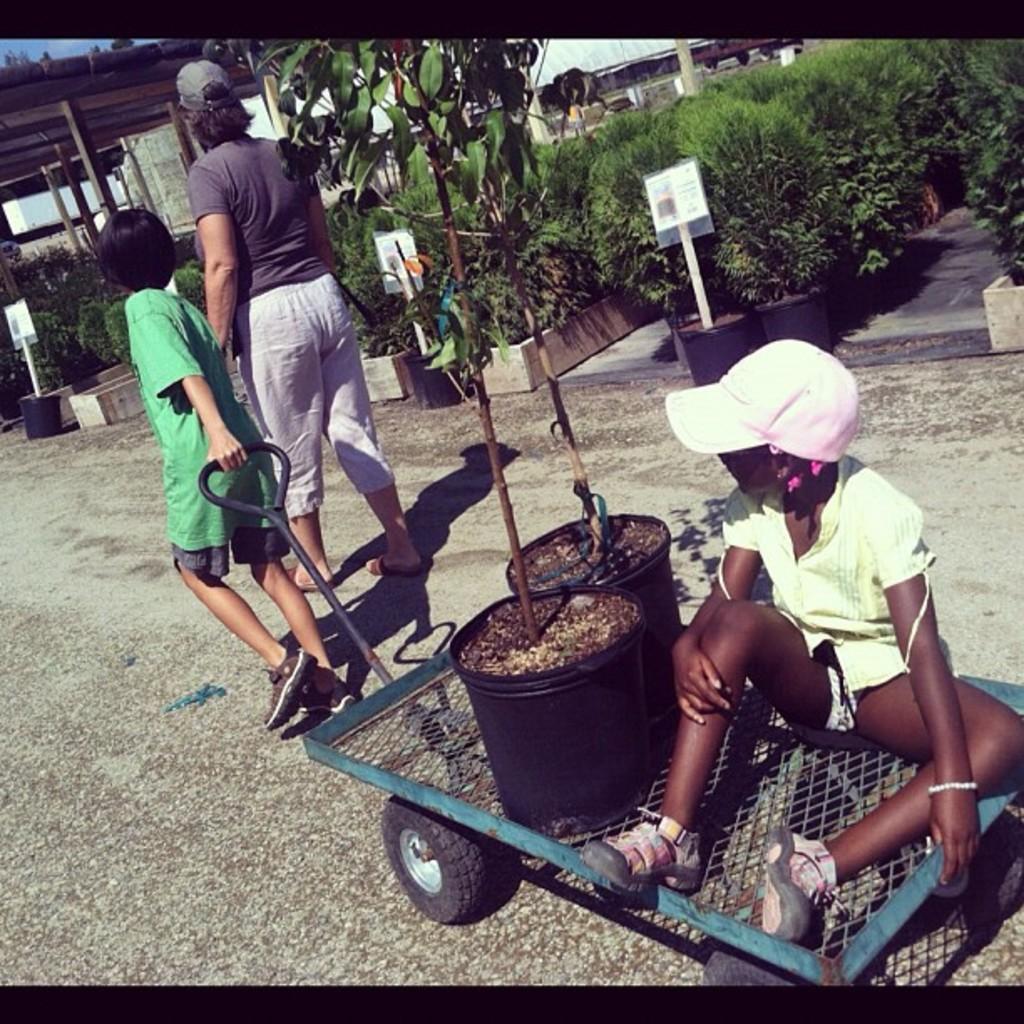Can you describe this image briefly? This image is taken outdoors. At the bottom of the image there is a road. In the background there are many plants in the pots. There are a few boards with a text on them. There is a tree with leaves, stems and branches. There is a shed. In the middle of the image a man and a kid are walking on the road and a kid is holding a trolley in the hand. There are two dots and a girl is sitting on the trolley. 